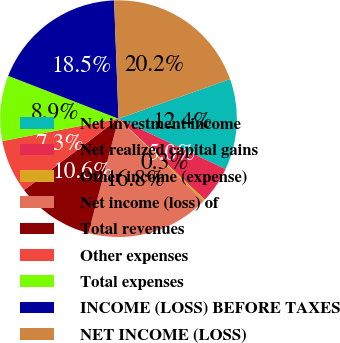<chart> <loc_0><loc_0><loc_500><loc_500><pie_chart><fcel>Net investment income<fcel>Net realized capital gains<fcel>Other income (expense)<fcel>Net income (loss) of<fcel>Total revenues<fcel>Other expenses<fcel>Total expenses<fcel>INCOME (LOSS) BEFORE TAXES<fcel>NET INCOME (LOSS)<nl><fcel>12.43%<fcel>4.98%<fcel>0.27%<fcel>16.84%<fcel>10.6%<fcel>7.27%<fcel>8.93%<fcel>18.51%<fcel>20.17%<nl></chart> 